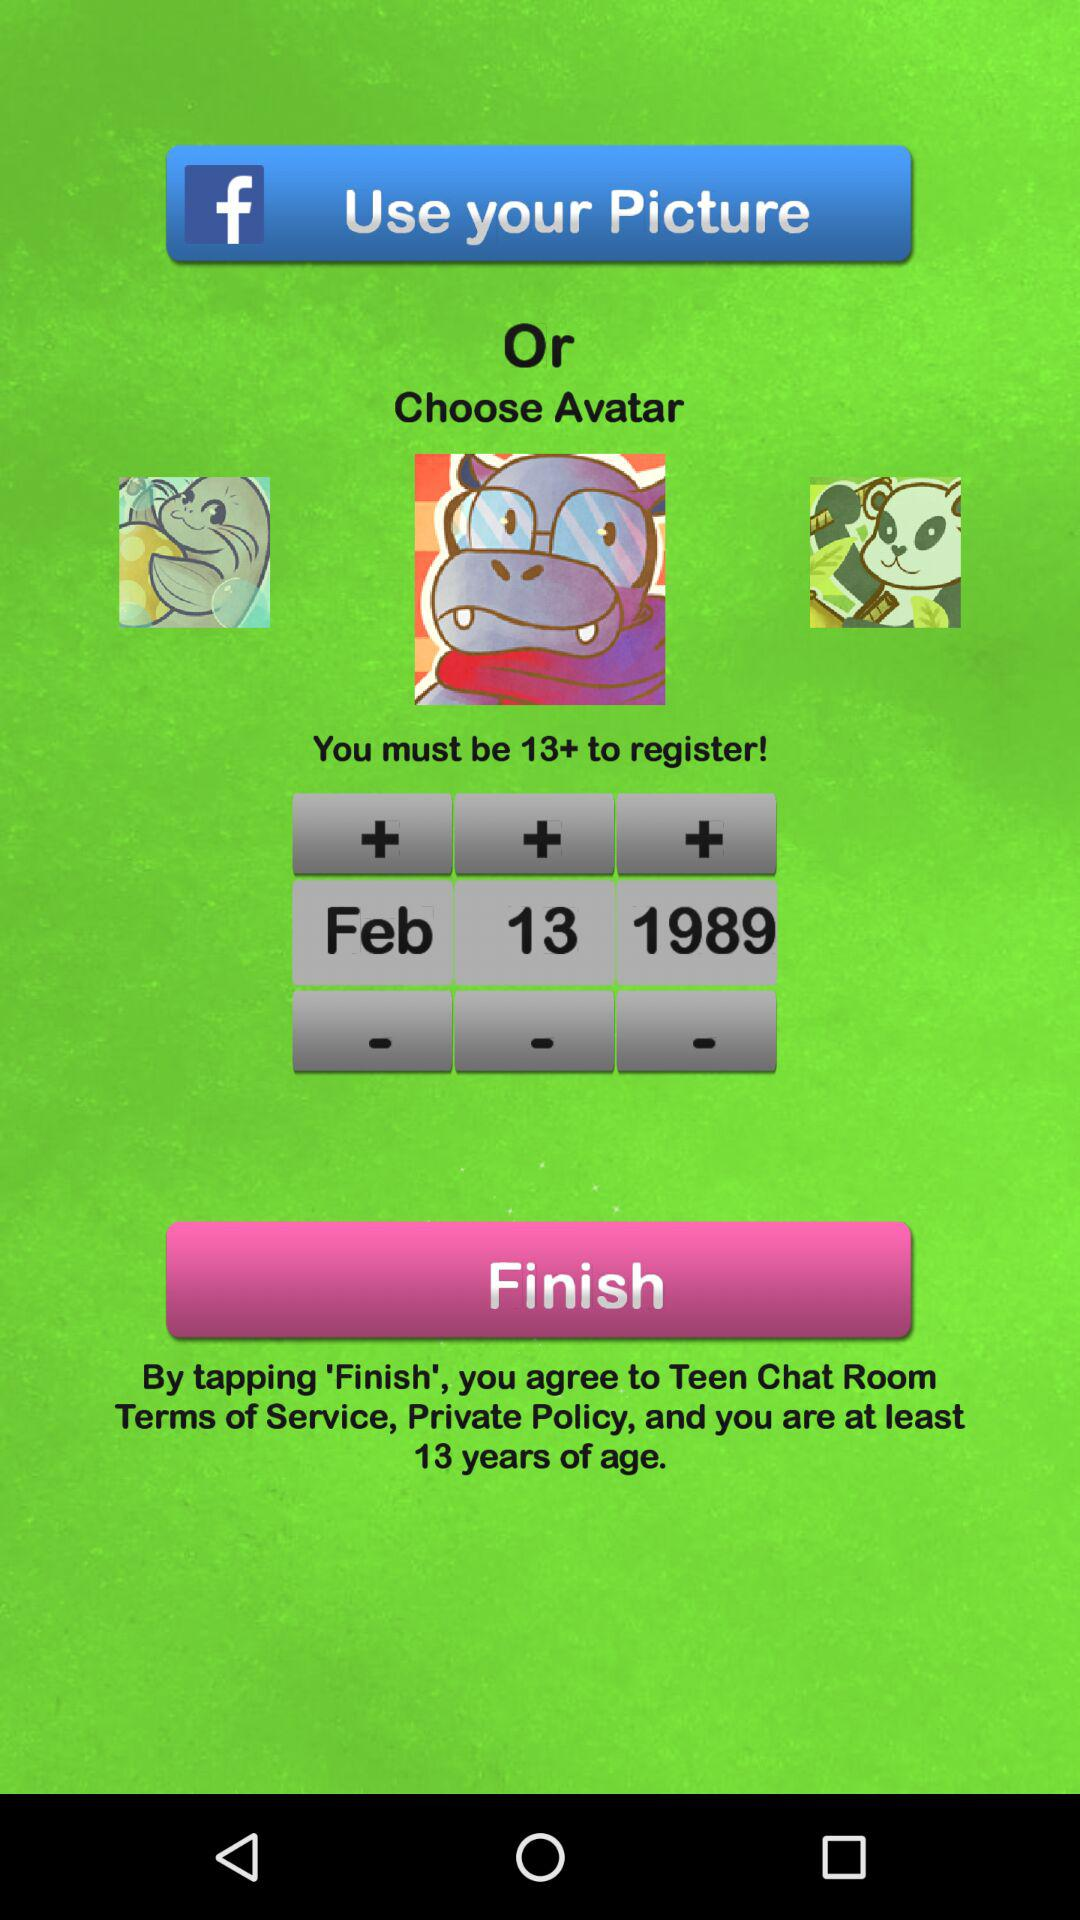How many avatar options are there?
Answer the question using a single word or phrase. 3 